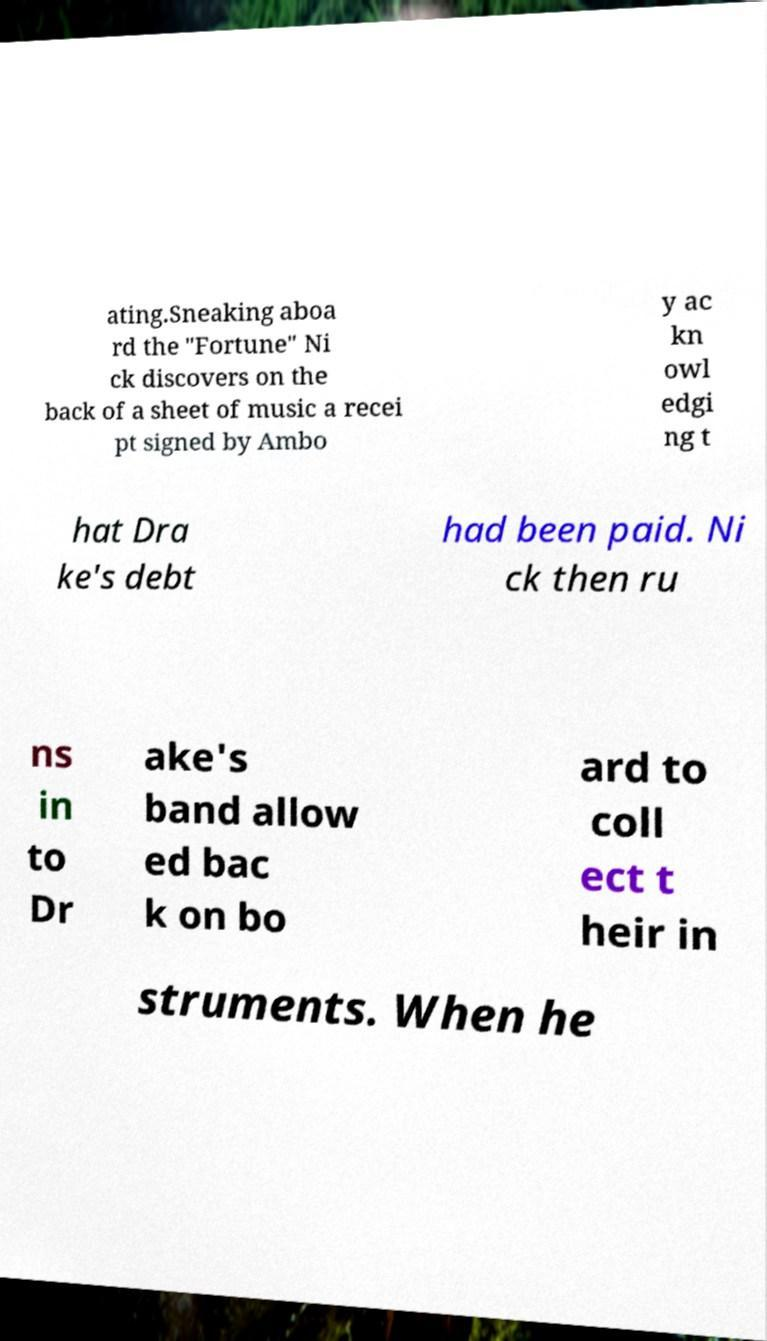Can you accurately transcribe the text from the provided image for me? ating.Sneaking aboa rd the "Fortune" Ni ck discovers on the back of a sheet of music a recei pt signed by Ambo y ac kn owl edgi ng t hat Dra ke's debt had been paid. Ni ck then ru ns in to Dr ake's band allow ed bac k on bo ard to coll ect t heir in struments. When he 